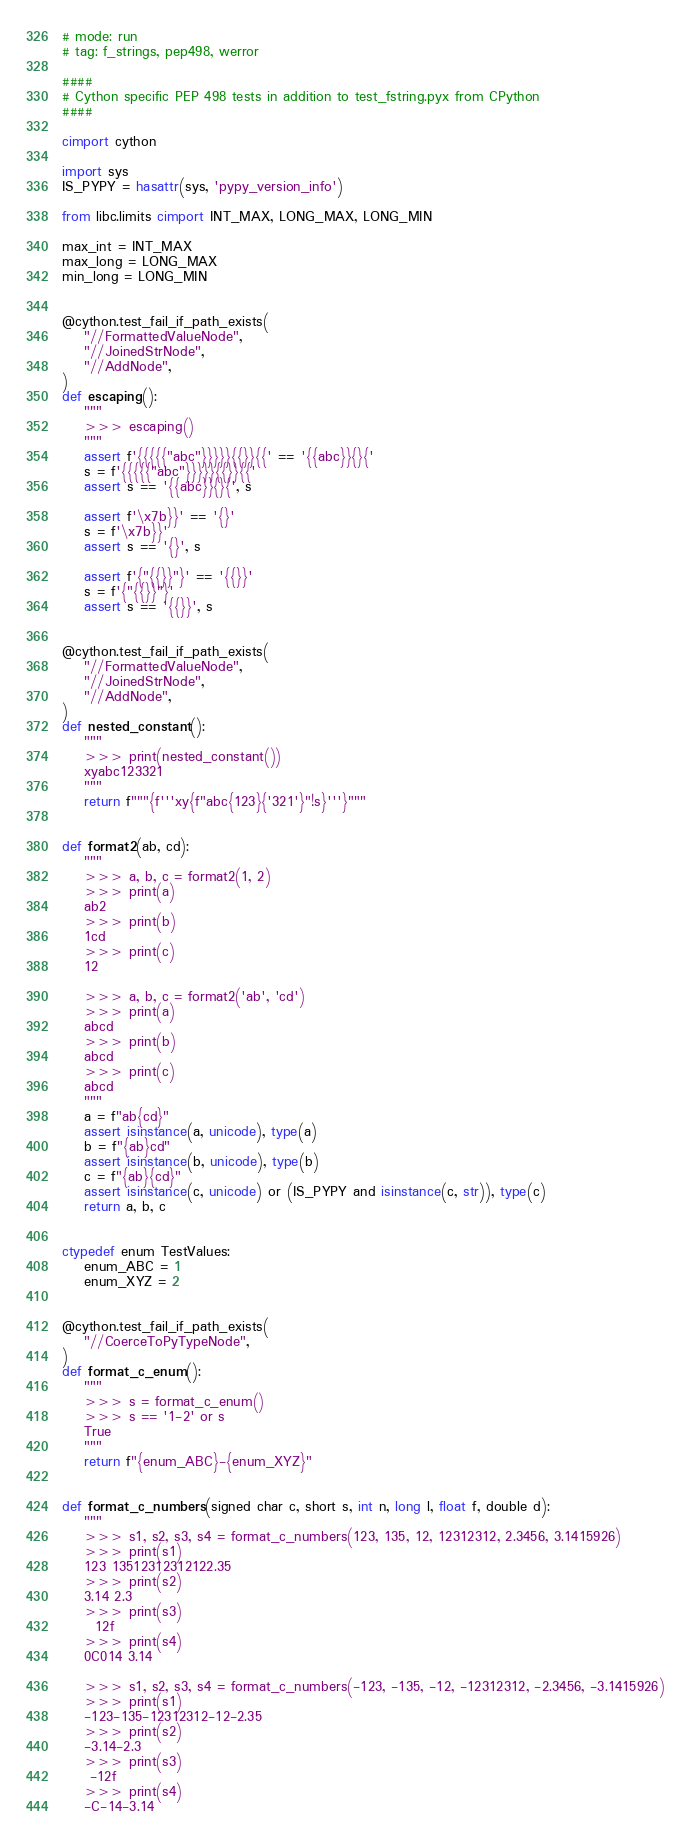<code> <loc_0><loc_0><loc_500><loc_500><_Cython_># mode: run
# tag: f_strings, pep498, werror

####
# Cython specific PEP 498 tests in addition to test_fstring.pyx from CPython
####

cimport cython

import sys
IS_PYPY = hasattr(sys, 'pypy_version_info')

from libc.limits cimport INT_MAX, LONG_MAX, LONG_MIN

max_int = INT_MAX
max_long = LONG_MAX
min_long = LONG_MIN


@cython.test_fail_if_path_exists(
    "//FormattedValueNode",
    "//JoinedStrNode",
    "//AddNode",
)
def escaping():
    """
    >>> escaping()
    """
    assert f'{{{{{"abc"}}}}}{{}}{{' == '{{abc}}{}{'
    s = f'{{{{{"abc"}}}}}{{}}{{'
    assert s == '{{abc}}{}{', s

    assert f'\x7b}}' == '{}'
    s = f'\x7b}}'
    assert s == '{}', s

    assert f'{"{{}}"}' == '{{}}'
    s = f'{"{{}}"}'
    assert s == '{{}}', s


@cython.test_fail_if_path_exists(
    "//FormattedValueNode",
    "//JoinedStrNode",
    "//AddNode",
)
def nested_constant():
    """
    >>> print(nested_constant())
    xyabc123321
    """
    return f"""{f'''xy{f"abc{123}{'321'}"!s}'''}"""


def format2(ab, cd):
    """
    >>> a, b, c = format2(1, 2)
    >>> print(a)
    ab2
    >>> print(b)
    1cd
    >>> print(c)
    12

    >>> a, b, c = format2('ab', 'cd')
    >>> print(a)
    abcd
    >>> print(b)
    abcd
    >>> print(c)
    abcd
    """
    a = f"ab{cd}"
    assert isinstance(a, unicode), type(a)
    b = f"{ab}cd"
    assert isinstance(b, unicode), type(b)
    c = f"{ab}{cd}"
    assert isinstance(c, unicode) or (IS_PYPY and isinstance(c, str)), type(c)
    return a, b, c


ctypedef enum TestValues:
    enum_ABC = 1
    enum_XYZ = 2


@cython.test_fail_if_path_exists(
    "//CoerceToPyTypeNode",
)
def format_c_enum():
    """
    >>> s = format_c_enum()
    >>> s == '1-2' or s
    True
    """
    return f"{enum_ABC}-{enum_XYZ}"


def format_c_numbers(signed char c, short s, int n, long l, float f, double d):
    """
    >>> s1, s2, s3, s4 = format_c_numbers(123, 135, 12, 12312312, 2.3456, 3.1415926)
    >>> print(s1)
    123 13512312312122.35
    >>> print(s2)
    3.14 2.3
    >>> print(s3)
      12f
    >>> print(s4)
    0C014 3.14

    >>> s1, s2, s3, s4 = format_c_numbers(-123, -135, -12, -12312312, -2.3456, -3.1415926)
    >>> print(s1)
    -123-135-12312312-12-2.35
    >>> print(s2)
    -3.14-2.3
    >>> print(s3)
     -12f
    >>> print(s4)
    -C-14-3.14
</code> 